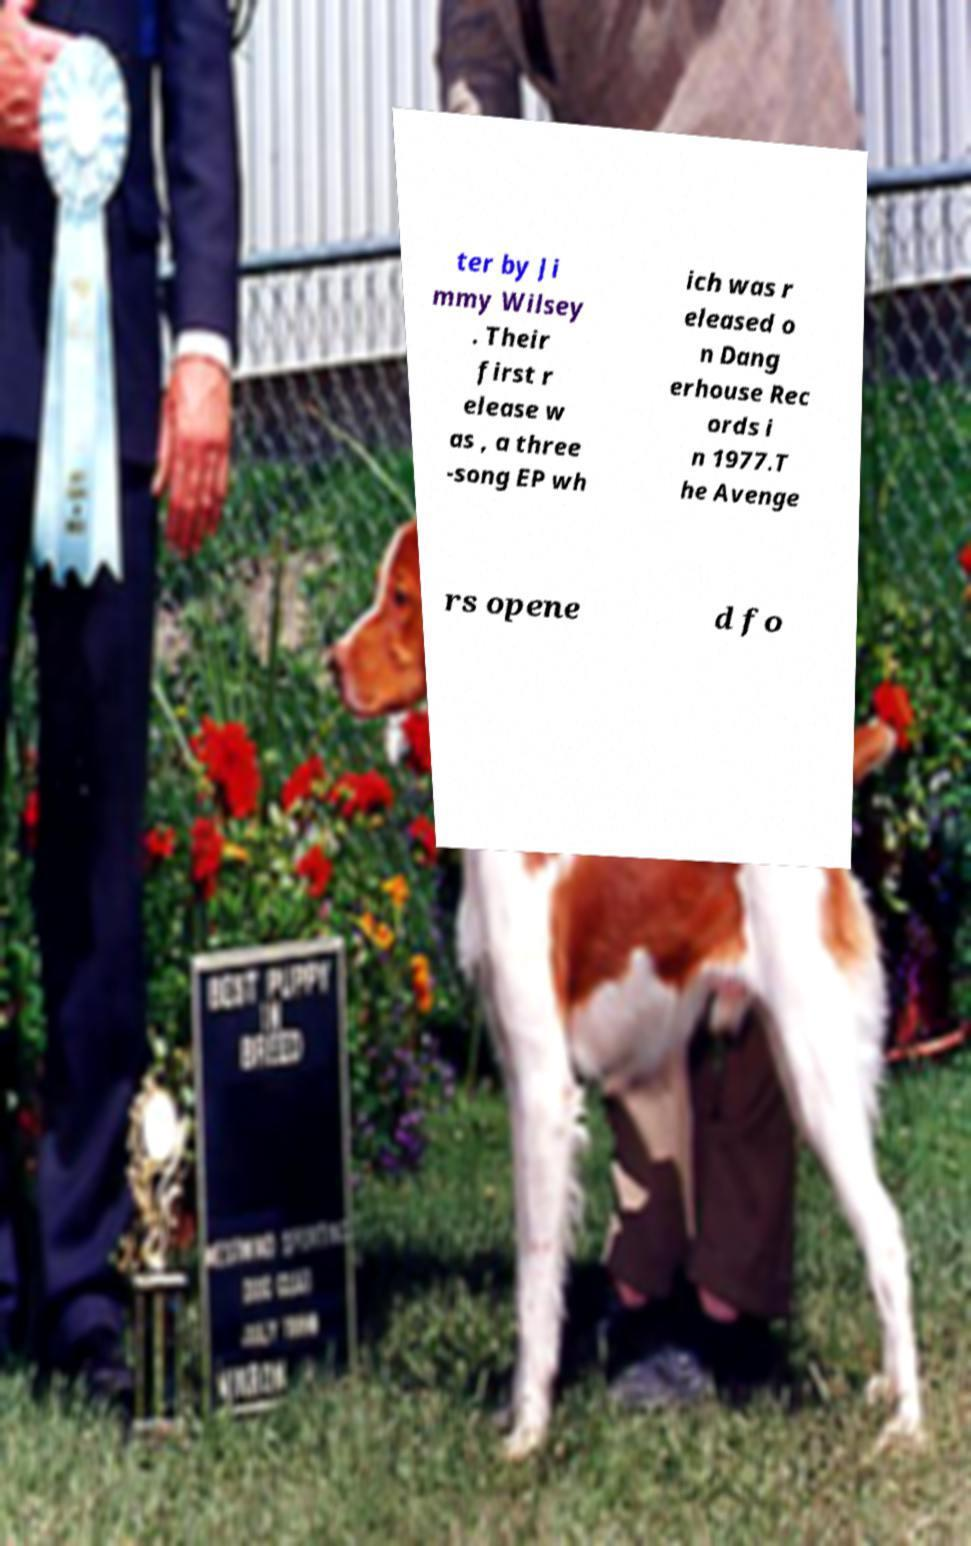Can you read and provide the text displayed in the image?This photo seems to have some interesting text. Can you extract and type it out for me? ter by Ji mmy Wilsey . Their first r elease w as , a three -song EP wh ich was r eleased o n Dang erhouse Rec ords i n 1977.T he Avenge rs opene d fo 